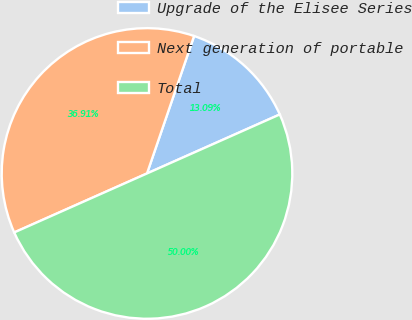Convert chart to OTSL. <chart><loc_0><loc_0><loc_500><loc_500><pie_chart><fcel>Upgrade of the Elisee Series<fcel>Next generation of portable<fcel>Total<nl><fcel>13.09%<fcel>36.91%<fcel>50.0%<nl></chart> 